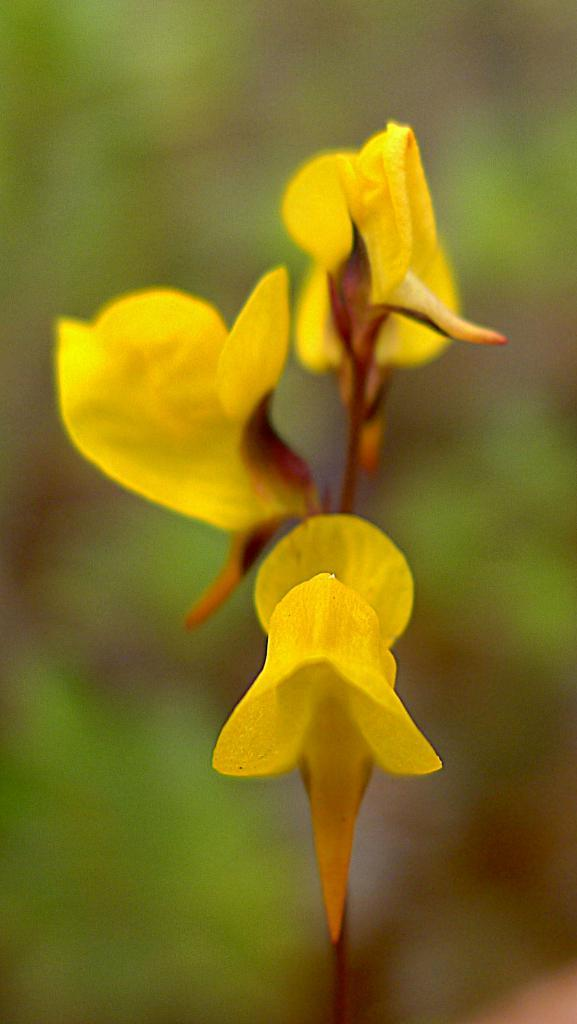What type of living organisms can be seen in the image? Flowers are visible in the image. What type of needle can be seen piercing the pear in the image? There is no pear or needle present in the image; it only contains flowers. 